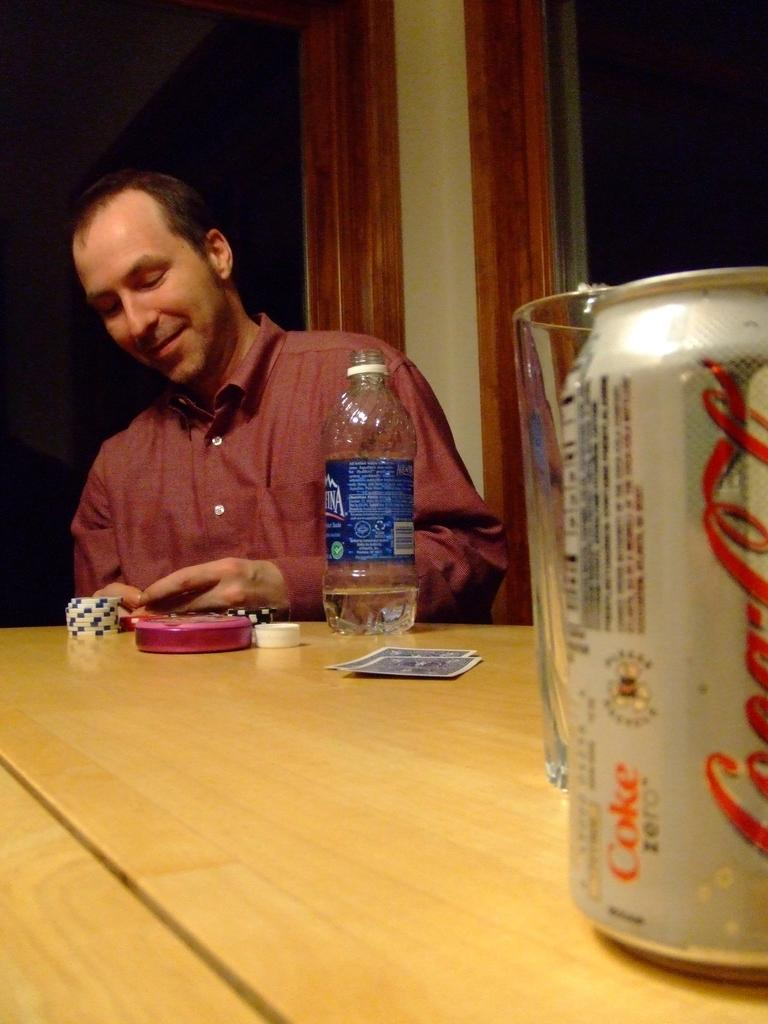<image>
Offer a succinct explanation of the picture presented. Man looking at something with an Aquafina bottle in front of him. 